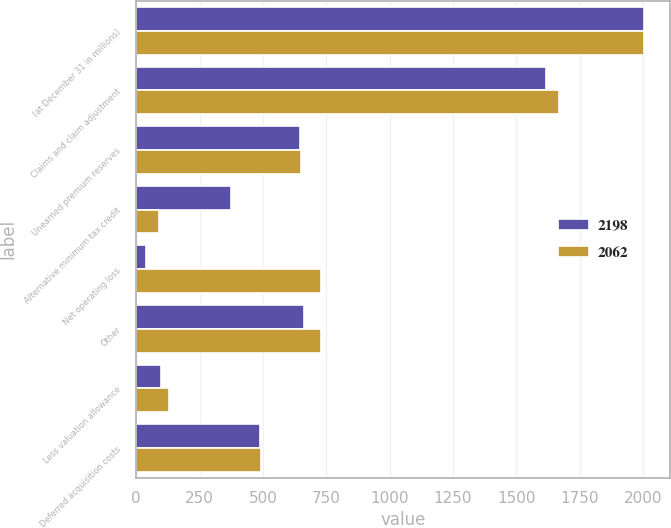Convert chart to OTSL. <chart><loc_0><loc_0><loc_500><loc_500><stacked_bar_chart><ecel><fcel>(at December 31 in millions)<fcel>Claims and claim adjustment<fcel>Unearned premium reserves<fcel>Alternative minimum tax credit<fcel>Net operating loss<fcel>Other<fcel>Less valuation allowance<fcel>Deferred acquisition costs<nl><fcel>2198<fcel>2005<fcel>1615<fcel>647<fcel>376<fcel>40<fcel>661<fcel>98<fcel>488<nl><fcel>2062<fcel>2004<fcel>1666<fcel>651<fcel>89<fcel>731<fcel>730<fcel>128<fcel>493<nl></chart> 